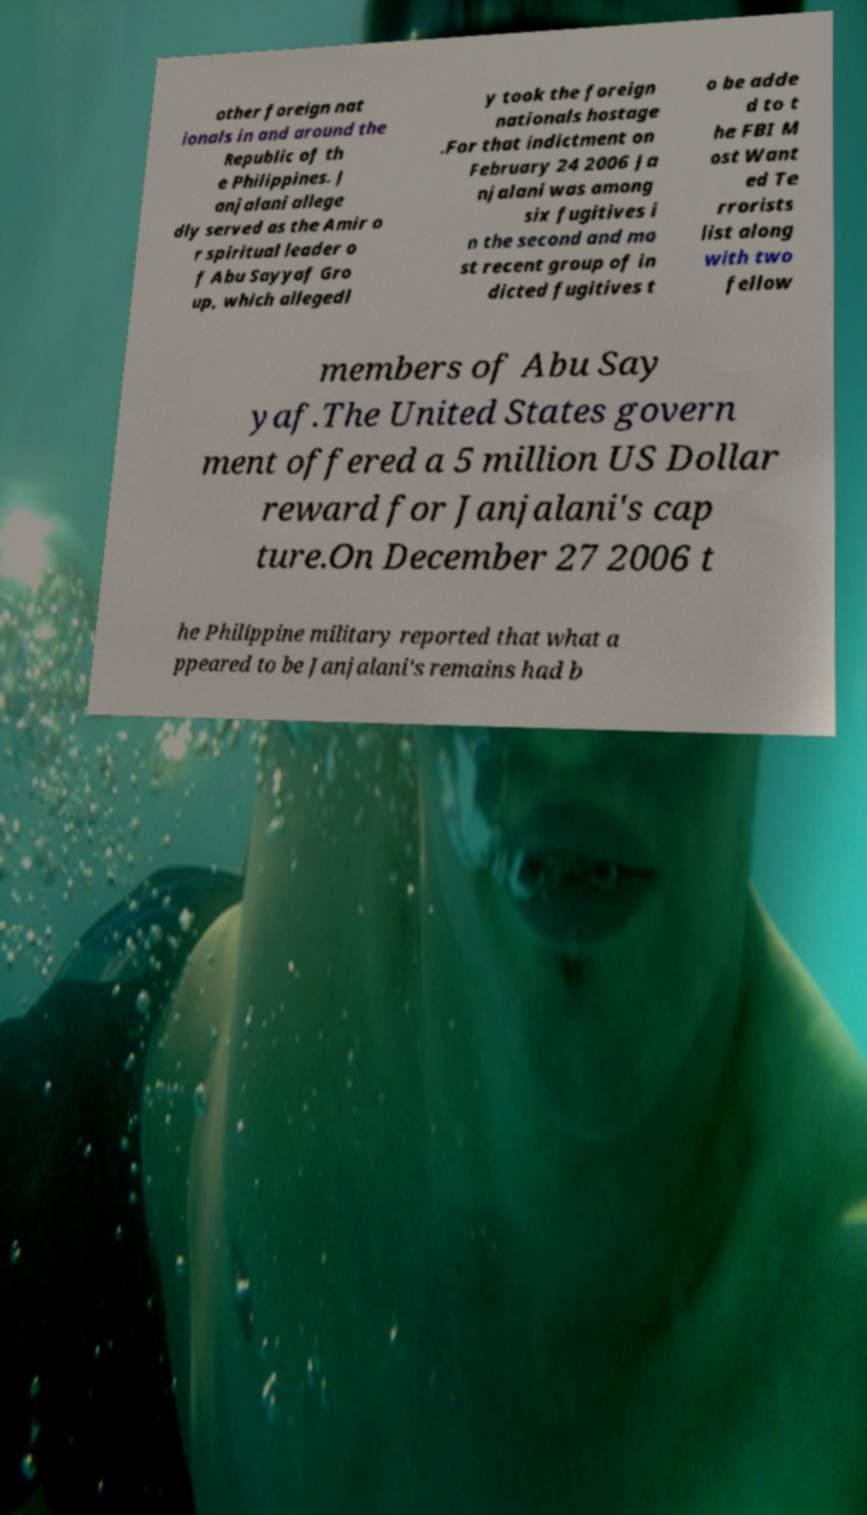Could you assist in decoding the text presented in this image and type it out clearly? other foreign nat ionals in and around the Republic of th e Philippines. J anjalani allege dly served as the Amir o r spiritual leader o f Abu Sayyaf Gro up, which allegedl y took the foreign nationals hostage .For that indictment on February 24 2006 Ja njalani was among six fugitives i n the second and mo st recent group of in dicted fugitives t o be adde d to t he FBI M ost Want ed Te rrorists list along with two fellow members of Abu Say yaf.The United States govern ment offered a 5 million US Dollar reward for Janjalani's cap ture.On December 27 2006 t he Philippine military reported that what a ppeared to be Janjalani's remains had b 